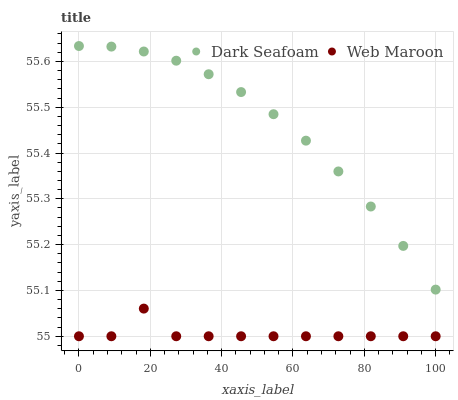Does Web Maroon have the minimum area under the curve?
Answer yes or no. Yes. Does Dark Seafoam have the maximum area under the curve?
Answer yes or no. Yes. Does Web Maroon have the maximum area under the curve?
Answer yes or no. No. Is Dark Seafoam the smoothest?
Answer yes or no. Yes. Is Web Maroon the roughest?
Answer yes or no. Yes. Is Web Maroon the smoothest?
Answer yes or no. No. Does Web Maroon have the lowest value?
Answer yes or no. Yes. Does Dark Seafoam have the highest value?
Answer yes or no. Yes. Does Web Maroon have the highest value?
Answer yes or no. No. Is Web Maroon less than Dark Seafoam?
Answer yes or no. Yes. Is Dark Seafoam greater than Web Maroon?
Answer yes or no. Yes. Does Web Maroon intersect Dark Seafoam?
Answer yes or no. No. 